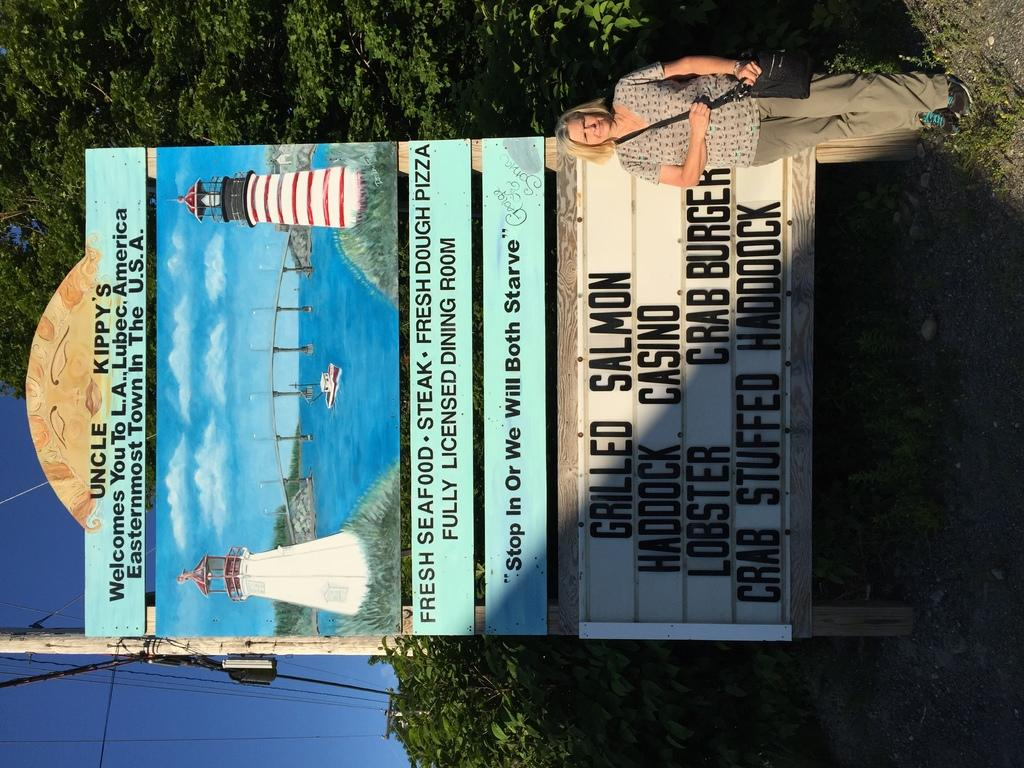<image>
Relay a brief, clear account of the picture shown. Fresh seafood and casinos are advertised on the board to this eastern most town of the United States. 